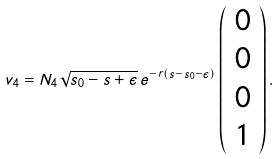<formula> <loc_0><loc_0><loc_500><loc_500>v _ { 4 } = N _ { 4 } \sqrt { s _ { 0 } - s + \epsilon } \, e ^ { - r ( s - s _ { 0 } - \epsilon ) } \left ( \begin{array} { c } 0 \\ 0 \\ 0 \\ 1 \end{array} \right ) .</formula> 